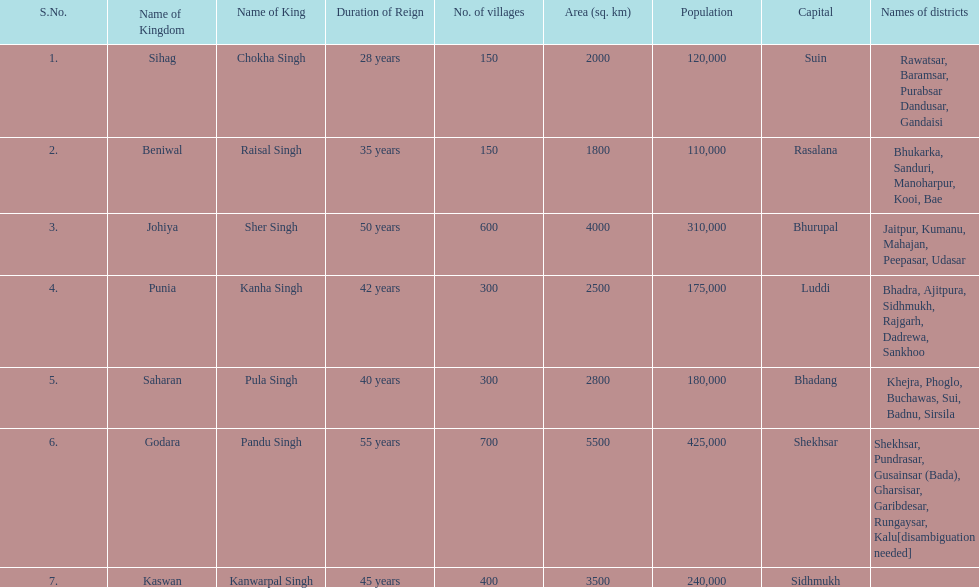How many districts does punia have? 6. 